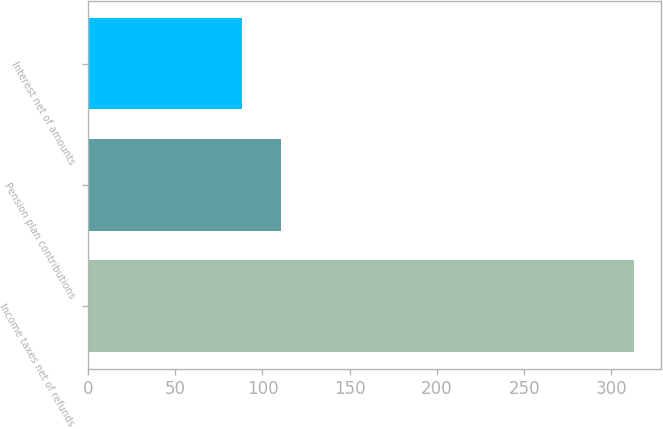Convert chart. <chart><loc_0><loc_0><loc_500><loc_500><bar_chart><fcel>Income taxes net of refunds<fcel>Pension plan contributions<fcel>Interest net of amounts<nl><fcel>313<fcel>110.5<fcel>88<nl></chart> 